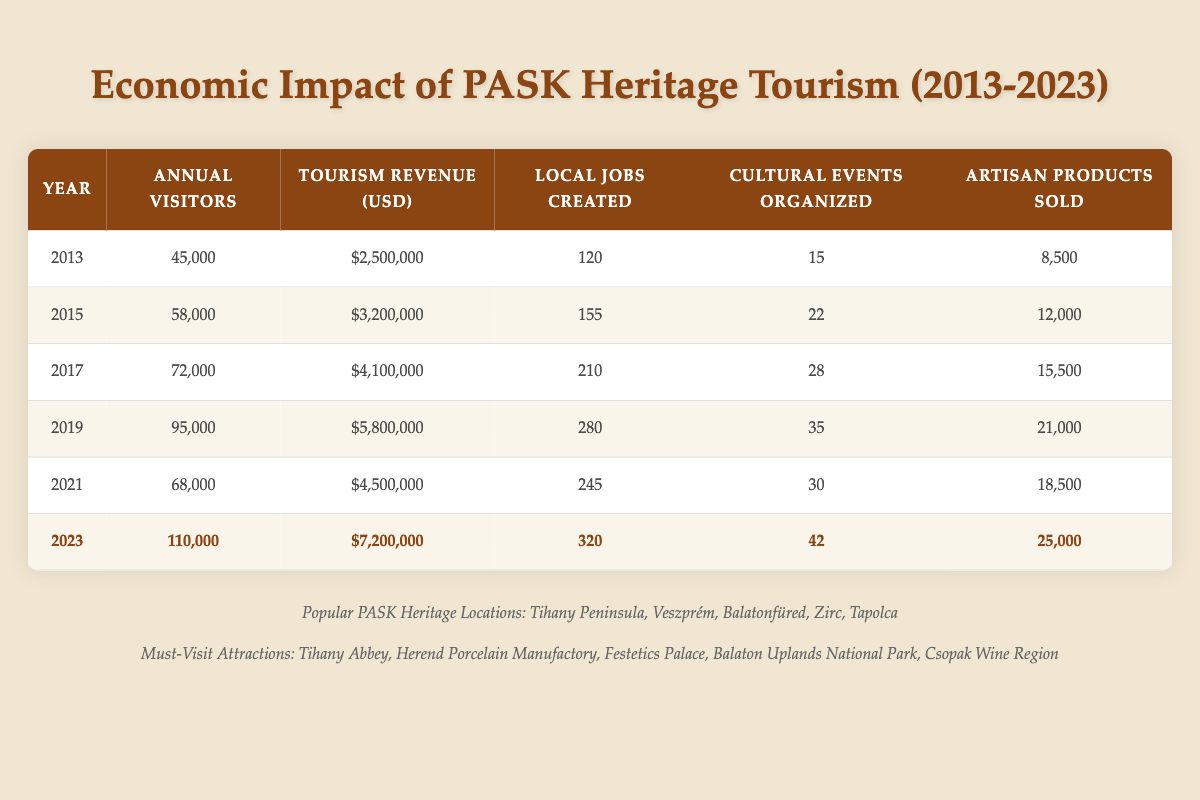What was the annual tourism revenue in 2019? According to the table, the annual tourism revenue for the year 2019 is listed as $5,800,000.
Answer: $5,800,000 How many local jobs were created in 2023? The table shows that in 2023, there were 320 local jobs created, as evident from the corresponding row for that year.
Answer: 320 What is the difference in annual visitors from 2013 to 2023? To determine the difference, subtract the number of annual visitors in 2013 (45,000) from that in 2023 (110,000). So, 110,000 - 45,000 = 65,000.
Answer: 65,000 Did more artisan products get sold in 2021 than in 2015? In 2021, 18,500 artisan products were sold, while in 2015, 12,000 were sold. Since 18,500 is greater than 12,000, the answer is yes.
Answer: Yes What was the average number of cultural events organized over the years from 2013 to 2023? The cultural events organized for each year are 15, 22, 28, 35, 30, and 42. Adding these gives 172 events. Dividing by the number of years (6) gives an average of 172 / 6 = 28.67, which can be rounded off to about 29.
Answer: 29 Which year had the highest number of annual visitors and how many were they? The table indicates that the highest number of annual visitors was in 2023, with 110,000 visitors recorded.
Answer: 110,000 Was there a decrease in tourism revenue from 2019 to 2021? From the table, in 2019, the tourism revenue was $5,800,000, while in 2021 it was $4,500,000. Since $4,500,000 is less than $5,800,000, there was indeed a decrease.
Answer: Yes How many more cultural events were organized in 2023 compared to 2015? The number of cultural events organized in 2023 was 42, and in 2015 it was 22. The difference is 42 - 22 = 20, indicating that 20 more events were organized in 2023.
Answer: 20 